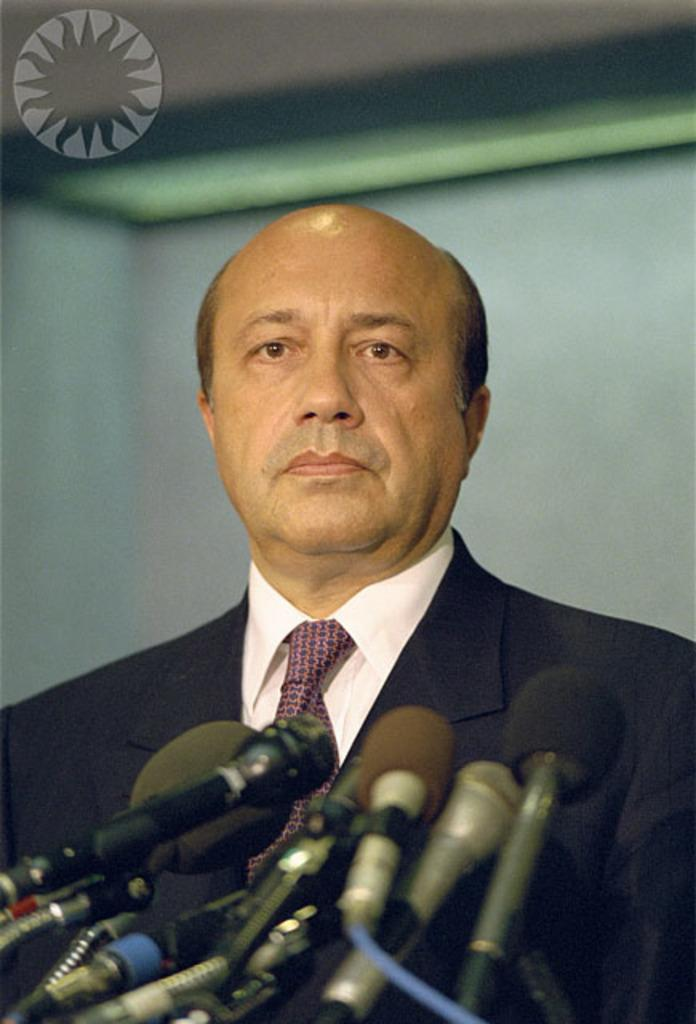Who or what is the main subject in the image? There is a person in the image. What is the person doing or interacting with in the image? The person is in front of microphones. What type of pies can be seen on the table in the image? There is no table or pies present in the image; it only features a person in front of microphones. 